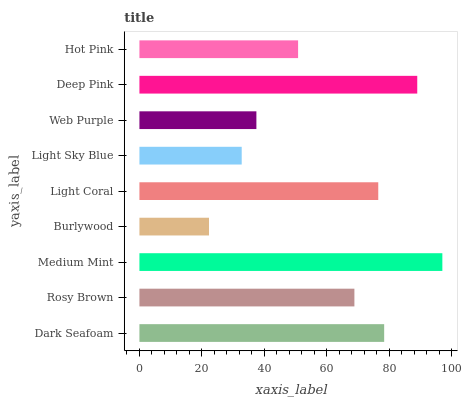Is Burlywood the minimum?
Answer yes or no. Yes. Is Medium Mint the maximum?
Answer yes or no. Yes. Is Rosy Brown the minimum?
Answer yes or no. No. Is Rosy Brown the maximum?
Answer yes or no. No. Is Dark Seafoam greater than Rosy Brown?
Answer yes or no. Yes. Is Rosy Brown less than Dark Seafoam?
Answer yes or no. Yes. Is Rosy Brown greater than Dark Seafoam?
Answer yes or no. No. Is Dark Seafoam less than Rosy Brown?
Answer yes or no. No. Is Rosy Brown the high median?
Answer yes or no. Yes. Is Rosy Brown the low median?
Answer yes or no. Yes. Is Web Purple the high median?
Answer yes or no. No. Is Light Sky Blue the low median?
Answer yes or no. No. 